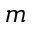Convert formula to latex. <formula><loc_0><loc_0><loc_500><loc_500>m</formula> 